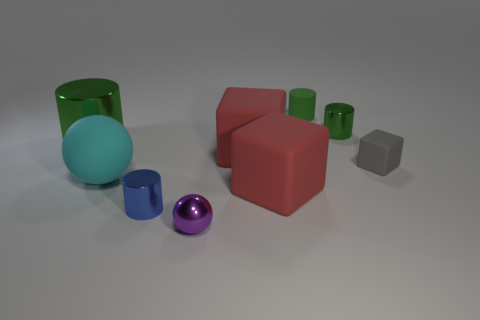The big green object is what shape?
Provide a short and direct response. Cylinder. Are there more green objects that are on the right side of the blue object than cyan cylinders?
Your answer should be very brief. Yes. Are there any other things that have the same shape as the cyan object?
Provide a short and direct response. Yes. There is a big matte thing that is the same shape as the purple metallic object; what is its color?
Keep it short and to the point. Cyan. What shape is the large matte object on the left side of the blue cylinder?
Provide a succinct answer. Sphere. There is a cyan matte object; are there any big red cubes to the left of it?
Your answer should be compact. No. Is there any other thing that has the same size as the blue shiny cylinder?
Provide a short and direct response. Yes. There is a big object that is made of the same material as the small purple sphere; what is its color?
Offer a terse response. Green. There is a small metal cylinder that is behind the big shiny object; does it have the same color as the matte thing that is left of the tiny purple ball?
Ensure brevity in your answer.  No. What number of cylinders are either large green objects or shiny objects?
Make the answer very short. 3. 